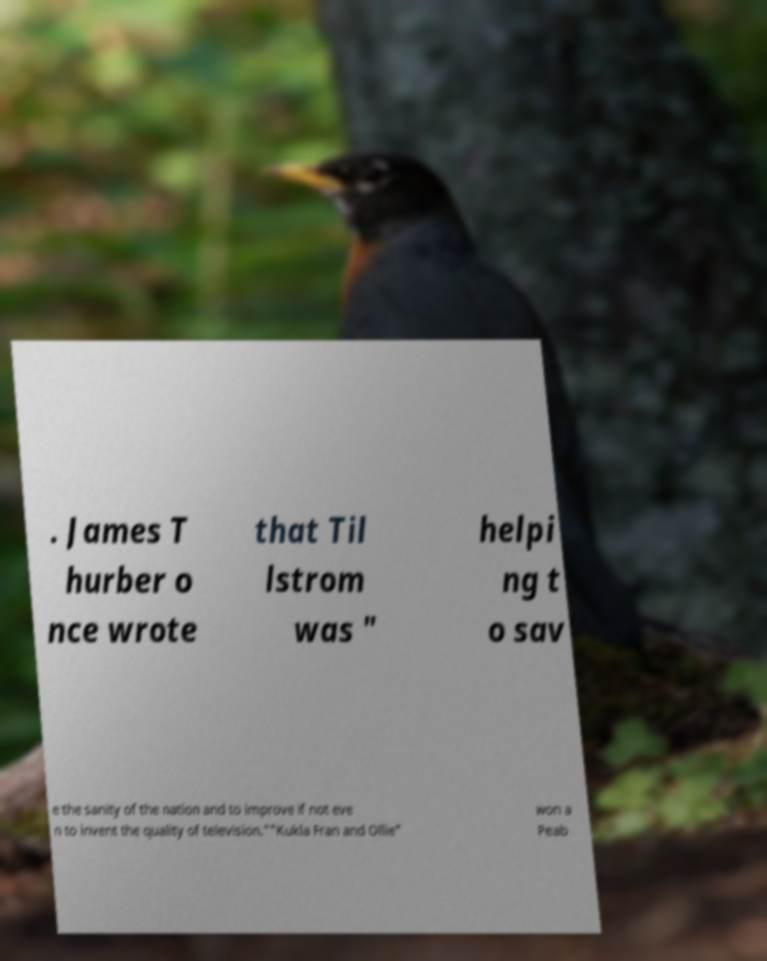Please read and relay the text visible in this image. What does it say? . James T hurber o nce wrote that Til lstrom was " helpi ng t o sav e the sanity of the nation and to improve if not eve n to invent the quality of television.""Kukla Fran and Ollie" won a Peab 